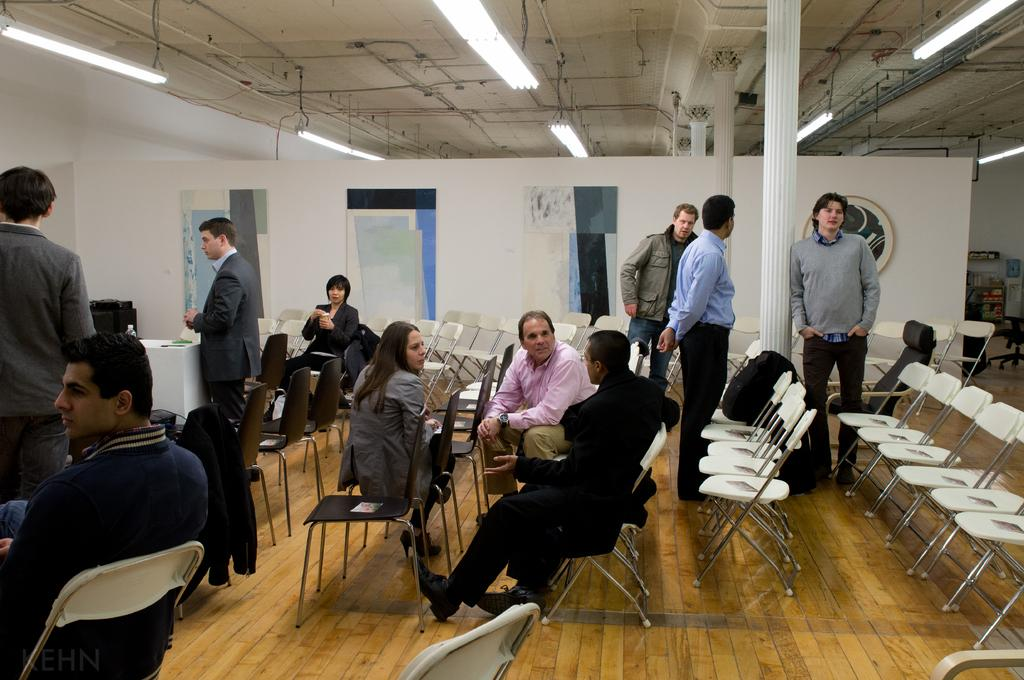What are the people in the image doing? There are persons sitting on chairs and standing on the right side of the image. Can you describe the lighting in the image? There are lights visible at the top of the image. What type of yak can be seen folding a kettle in the image? There is no yak or kettle present in the image. 